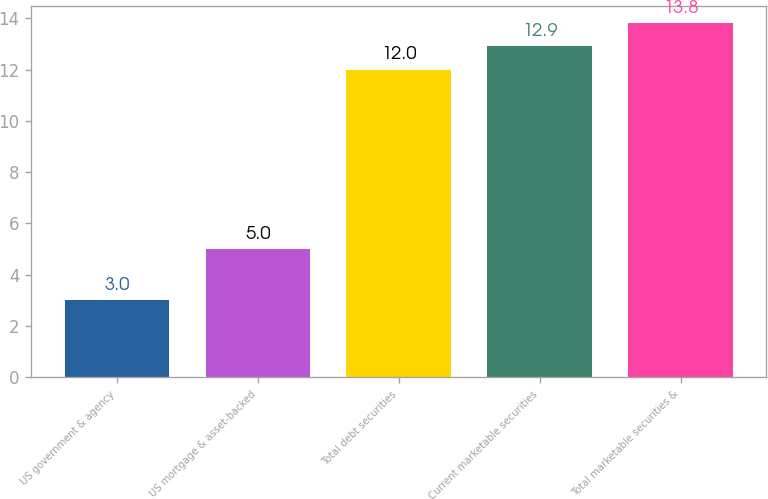Convert chart. <chart><loc_0><loc_0><loc_500><loc_500><bar_chart><fcel>US government & agency<fcel>US mortgage & asset-backed<fcel>Total debt securities<fcel>Current marketable securities<fcel>Total marketable securities &<nl><fcel>3<fcel>5<fcel>12<fcel>12.9<fcel>13.8<nl></chart> 